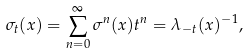Convert formula to latex. <formula><loc_0><loc_0><loc_500><loc_500>\sigma _ { t } ( x ) = \sum _ { n = 0 } ^ { \infty } \sigma ^ { n } ( x ) t ^ { n } = \lambda _ { - t } ( x ) ^ { - 1 } ,</formula> 